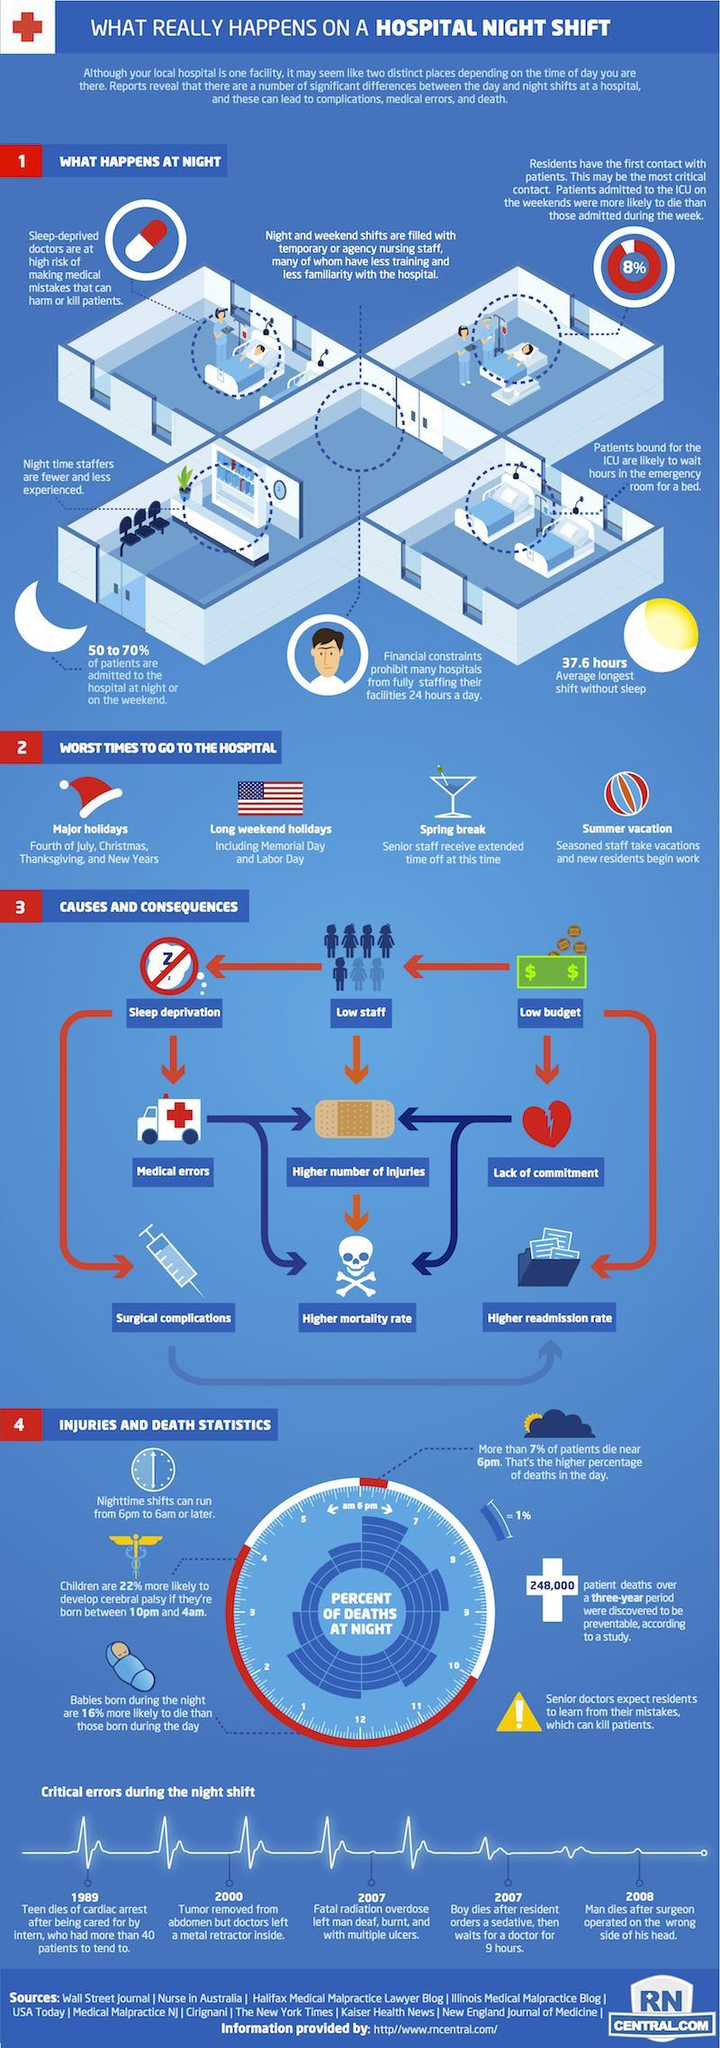What is the average longest shifts in hospitals without sleep?
Answer the question with a short phrase. 37.6 hours 